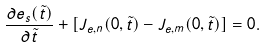<formula> <loc_0><loc_0><loc_500><loc_500>\frac { \partial e _ { s } ( \tilde { t } ) } { \partial \tilde { t } } + [ J _ { e , n } ( 0 , \tilde { t } ) - J _ { e , m } ( 0 , \tilde { t } ) ] = 0 .</formula> 